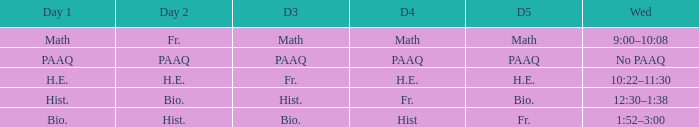What is the day 1 when the day 3 is math? Math. 